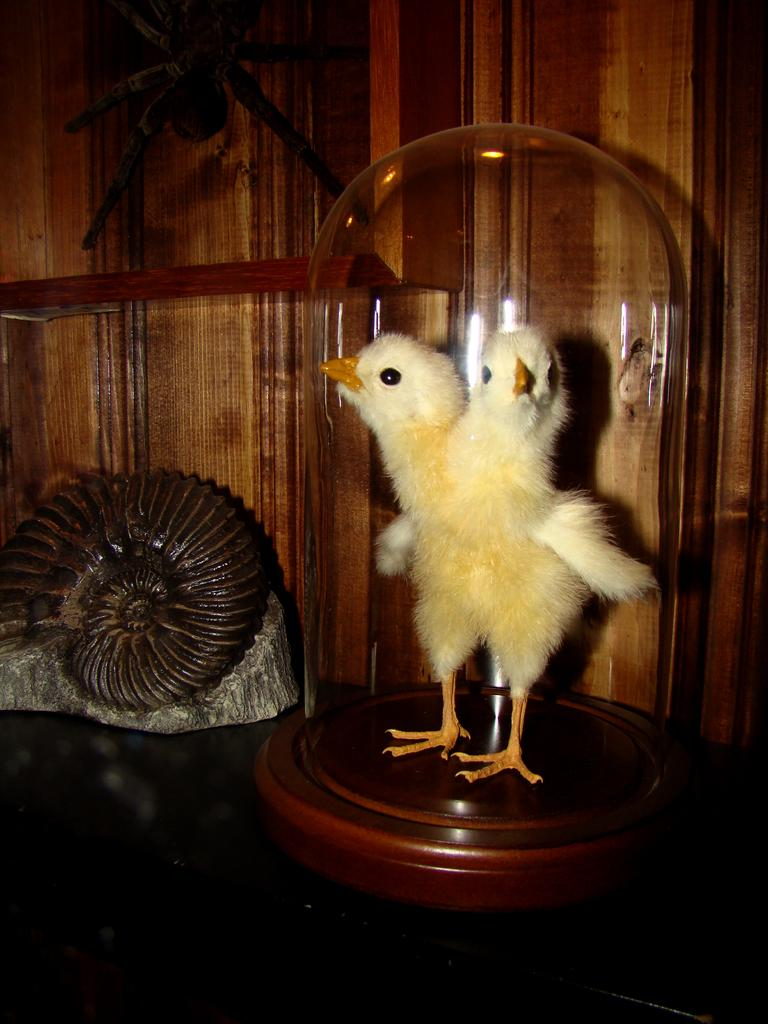What is the main subject of the image? There is a depiction of a chick in the center of the image. What can be seen in the background of the image? There is a wooden wall in the background of the image. What is located to the left side of the image? There is an object to the left side of the image. What type of stew is being prepared in the scene depicted in the image? There is no scene or stew present in the image; it features a depiction of a chick and a wooden wall. 